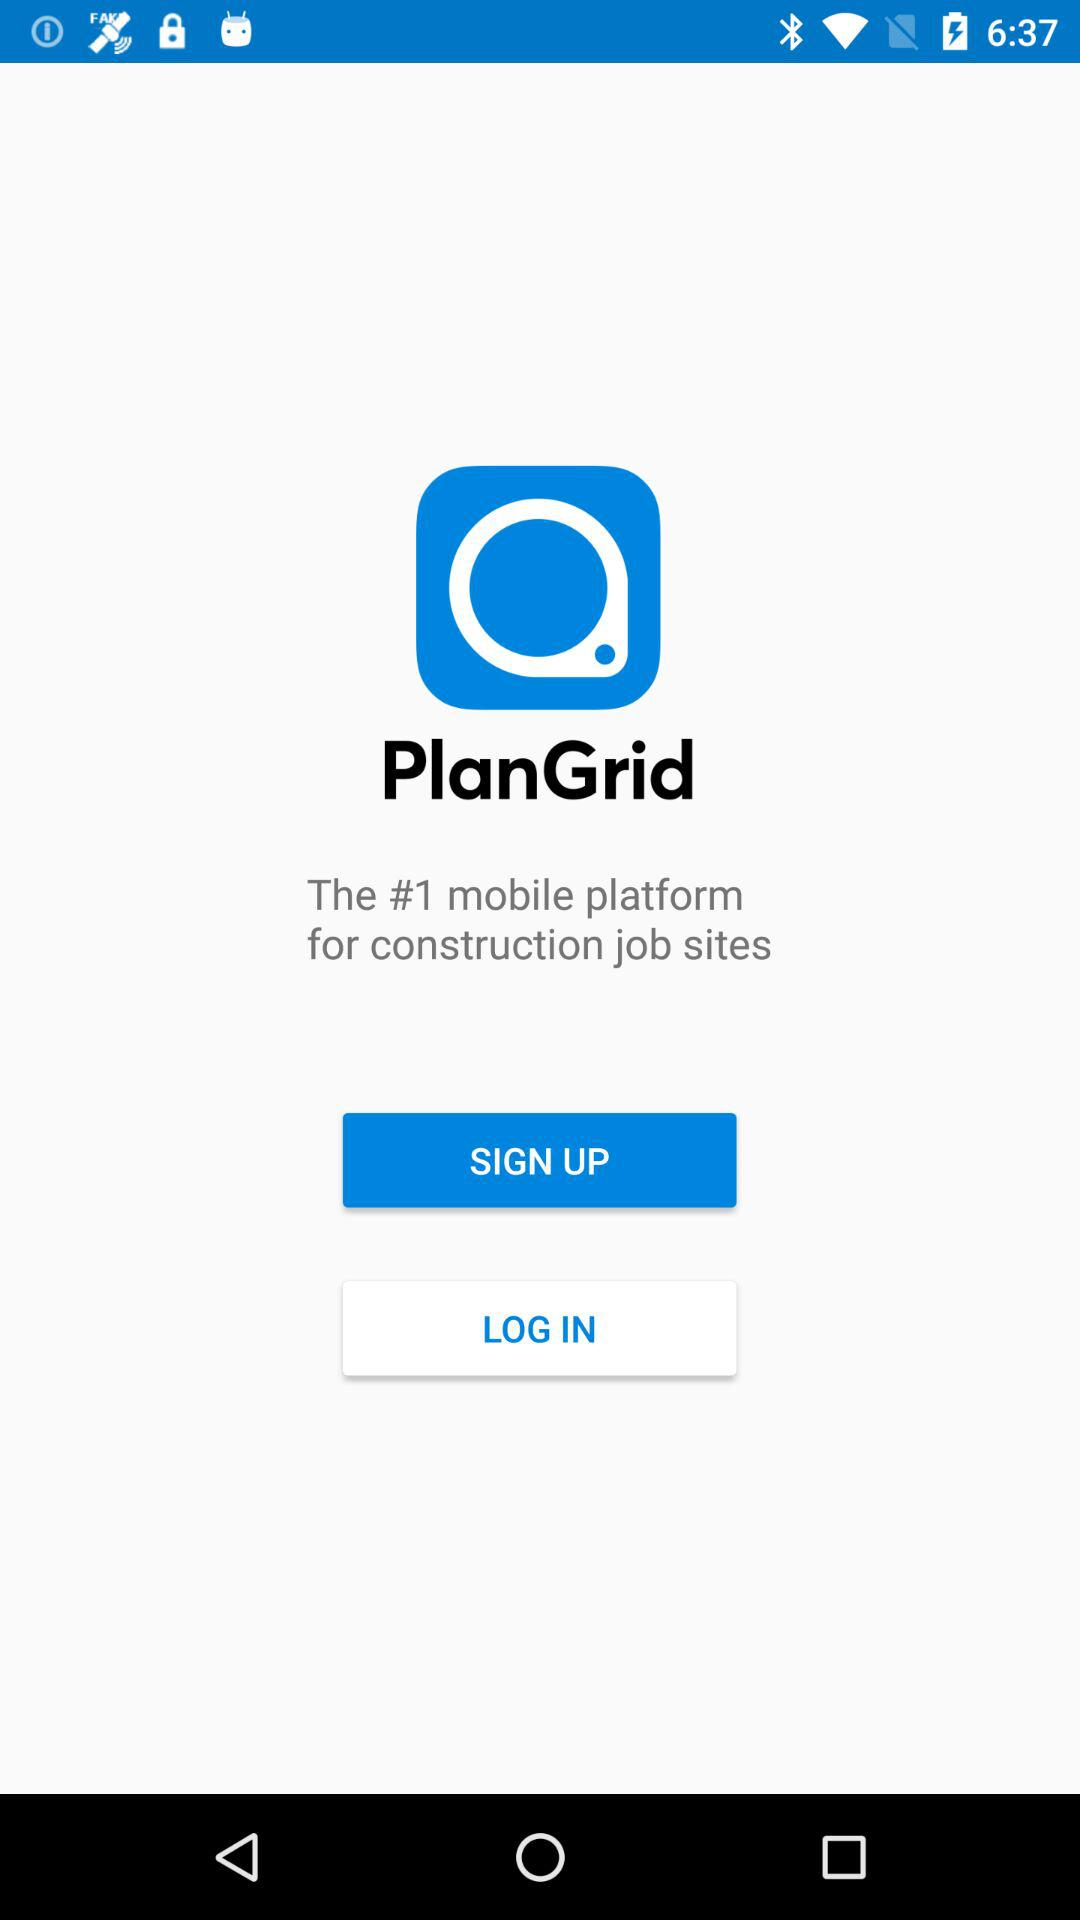What type of job site is the application for? The application is for construction job sites. 